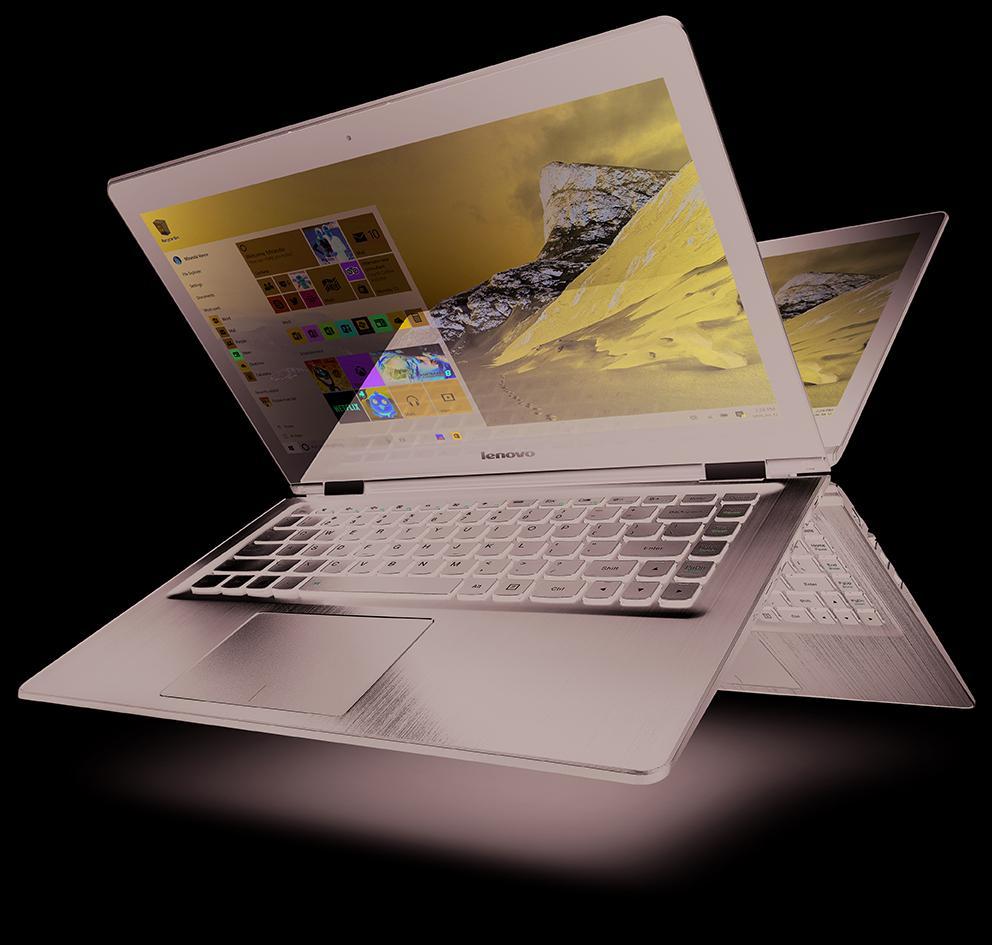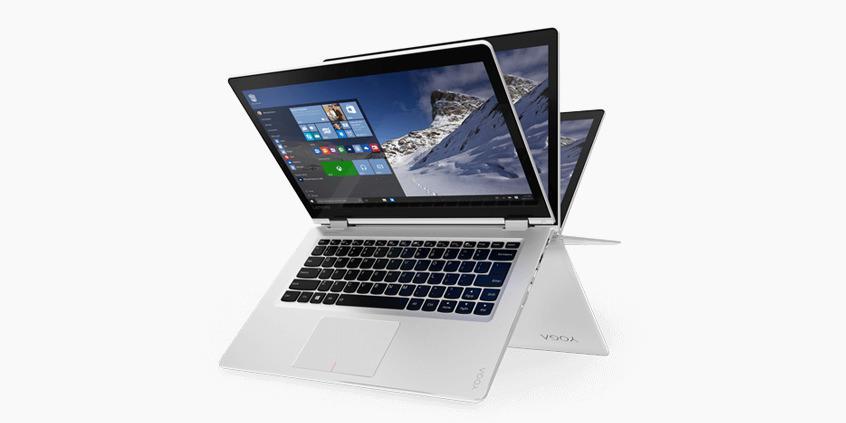The first image is the image on the left, the second image is the image on the right. For the images displayed, is the sentence "There are at least 3 laptops in the image on the left." factually correct? Answer yes or no. No. 